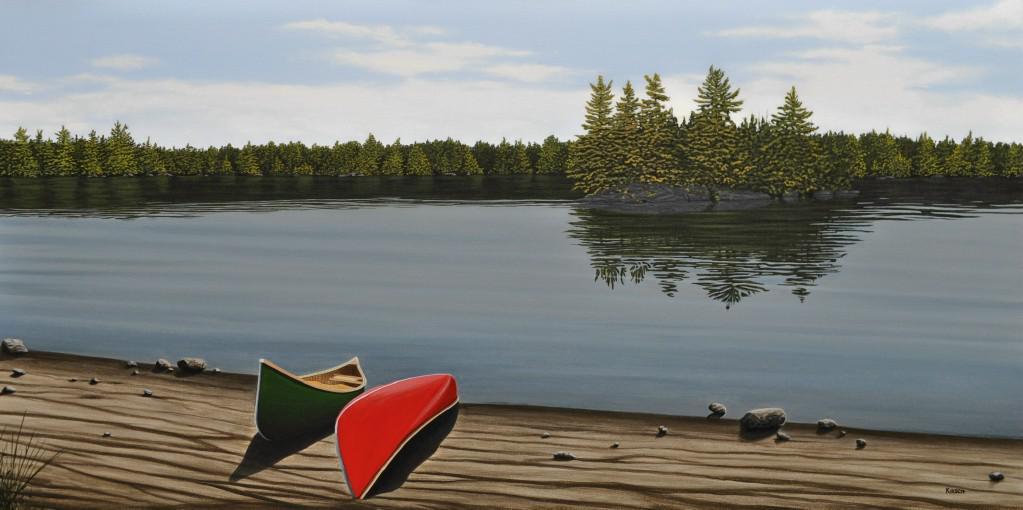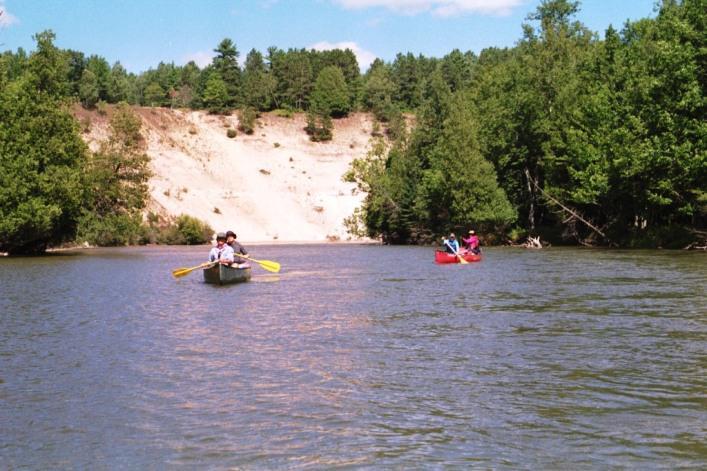The first image is the image on the left, the second image is the image on the right. For the images displayed, is the sentence "At least one image shows watercraft that is pulled up to the edge of the water." factually correct? Answer yes or no. Yes. The first image is the image on the left, the second image is the image on the right. For the images displayed, is the sentence "There are canoes sitting on the beach" factually correct? Answer yes or no. Yes. 